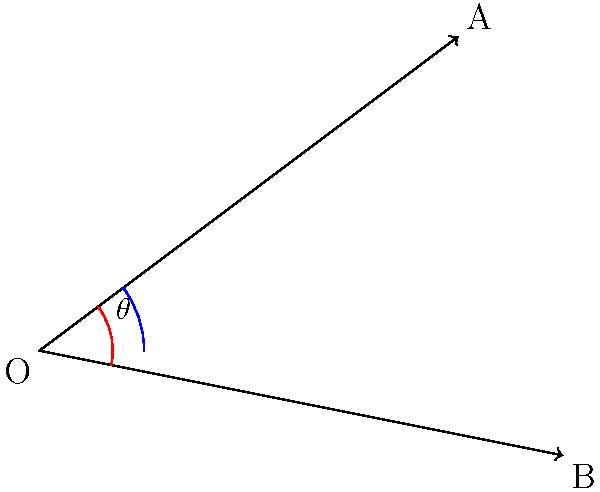As you explore two paths leading to different healing herb collection areas, you notice they form an angle. Path OA leads to a medicinal root area, while path OB leads to a sacred leaf gathering spot. Given that path OA has coordinates (4, 3) and path OB has coordinates (5, -1), what is the angle $\theta$ between these two paths in degrees? To find the angle between two vectors, we can use the dot product formula and inverse cosine function. Let's solve this step-by-step:

1) First, we need to calculate the dot product of the two vectors:
   $\vec{OA} \cdot \vec{OB} = 4(5) + 3(-1) = 20 - 3 = 17$

2) Next, we calculate the magnitudes of the vectors:
   $|\vec{OA}| = \sqrt{4^2 + 3^2} = \sqrt{16 + 9} = \sqrt{25} = 5$
   $|\vec{OB}| = \sqrt{5^2 + (-1)^2} = \sqrt{25 + 1} = \sqrt{26}$

3) Now we can use the dot product formula:
   $\cos \theta = \frac{\vec{OA} \cdot \vec{OB}}{|\vec{OA}||\vec{OB}|}$

4) Substituting our values:
   $\cos \theta = \frac{17}{5\sqrt{26}}$

5) To find $\theta$, we take the inverse cosine (arccos) of both sides:
   $\theta = \arccos(\frac{17}{5\sqrt{26}})$

6) Using a calculator or computer, we can evaluate this:
   $\theta \approx 0.7972$ radians

7) Convert to degrees:
   $\theta \approx 0.7972 \times \frac{180}{\pi} \approx 45.66°$
Answer: $45.66°$ 